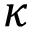<formula> <loc_0><loc_0><loc_500><loc_500>\kappa</formula> 